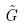Convert formula to latex. <formula><loc_0><loc_0><loc_500><loc_500>\tilde { G }</formula> 